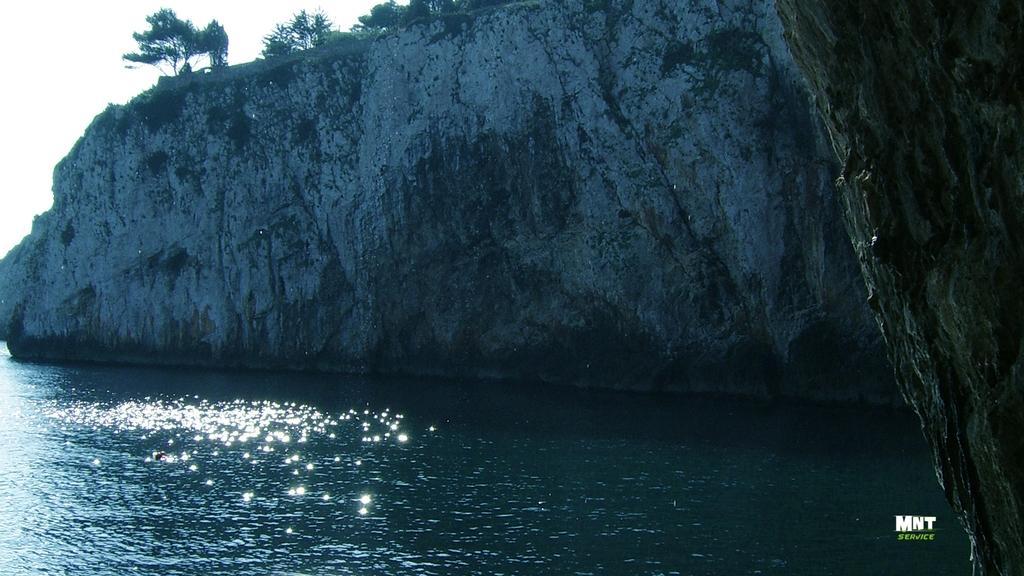Describe this image in one or two sentences. On the left side, there is water. On the bottom right, there is a watermark. On the right side, there is a hill. In the background, there is a mountain and there is sky. 